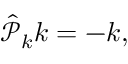Convert formula to latex. <formula><loc_0><loc_0><loc_500><loc_500>\begin{array} { r } { \hat { \mathcal { P } } _ { k } k = - k , } \end{array}</formula> 